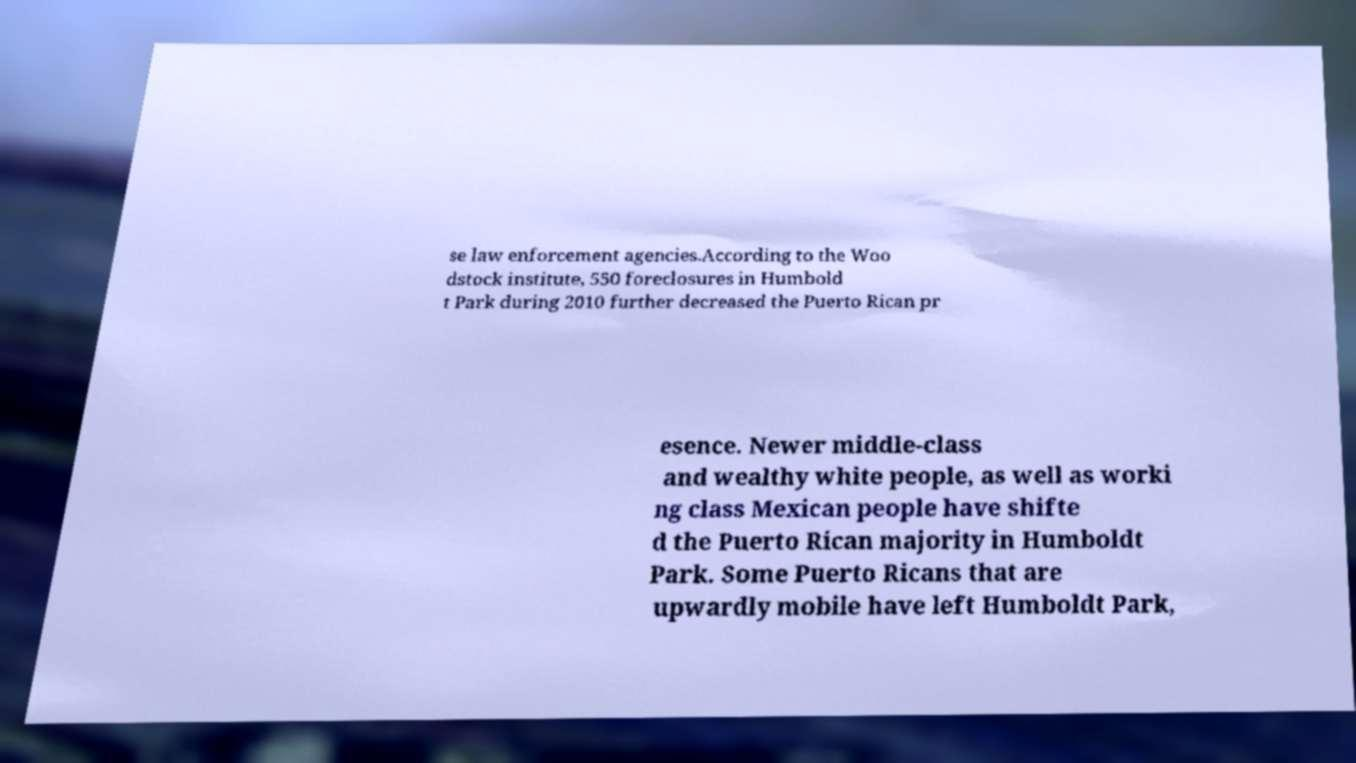Could you extract and type out the text from this image? se law enforcement agencies.According to the Woo dstock institute, 550 foreclosures in Humbold t Park during 2010 further decreased the Puerto Rican pr esence. Newer middle-class and wealthy white people, as well as worki ng class Mexican people have shifte d the Puerto Rican majority in Humboldt Park. Some Puerto Ricans that are upwardly mobile have left Humboldt Park, 